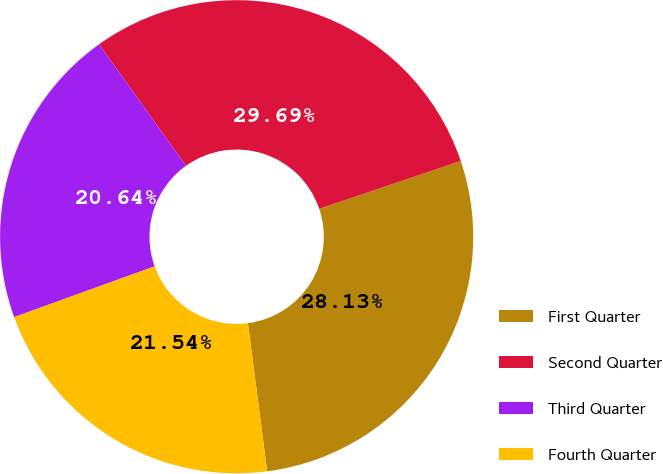Convert chart to OTSL. <chart><loc_0><loc_0><loc_500><loc_500><pie_chart><fcel>First Quarter<fcel>Second Quarter<fcel>Third Quarter<fcel>Fourth Quarter<nl><fcel>28.13%<fcel>29.69%<fcel>20.64%<fcel>21.54%<nl></chart> 